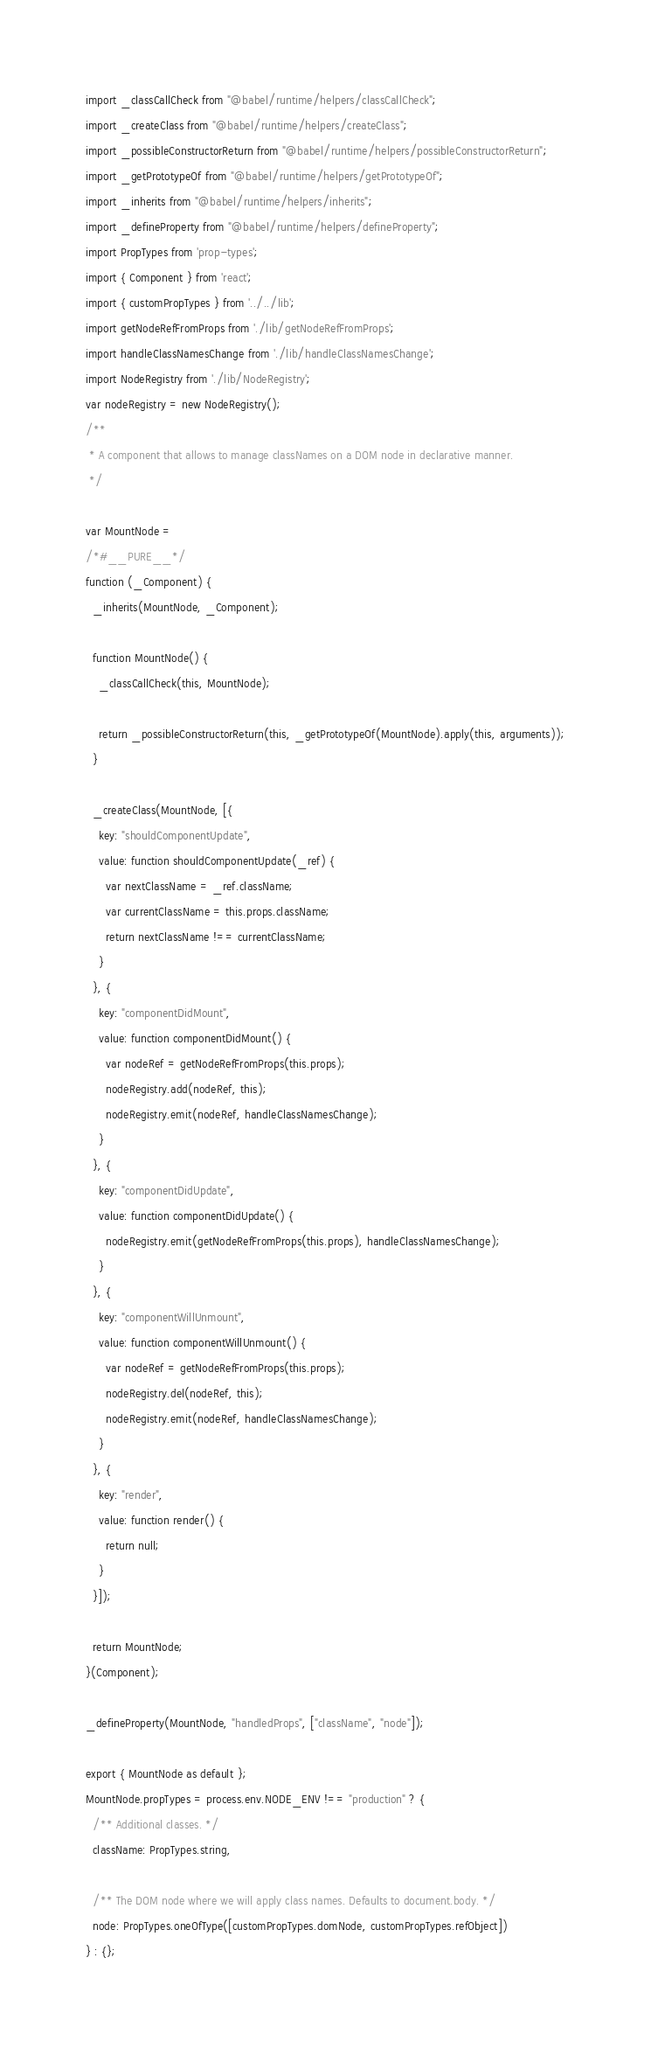<code> <loc_0><loc_0><loc_500><loc_500><_JavaScript_>import _classCallCheck from "@babel/runtime/helpers/classCallCheck";
import _createClass from "@babel/runtime/helpers/createClass";
import _possibleConstructorReturn from "@babel/runtime/helpers/possibleConstructorReturn";
import _getPrototypeOf from "@babel/runtime/helpers/getPrototypeOf";
import _inherits from "@babel/runtime/helpers/inherits";
import _defineProperty from "@babel/runtime/helpers/defineProperty";
import PropTypes from 'prop-types';
import { Component } from 'react';
import { customPropTypes } from '../../lib';
import getNodeRefFromProps from './lib/getNodeRefFromProps';
import handleClassNamesChange from './lib/handleClassNamesChange';
import NodeRegistry from './lib/NodeRegistry';
var nodeRegistry = new NodeRegistry();
/**
 * A component that allows to manage classNames on a DOM node in declarative manner.
 */

var MountNode =
/*#__PURE__*/
function (_Component) {
  _inherits(MountNode, _Component);

  function MountNode() {
    _classCallCheck(this, MountNode);

    return _possibleConstructorReturn(this, _getPrototypeOf(MountNode).apply(this, arguments));
  }

  _createClass(MountNode, [{
    key: "shouldComponentUpdate",
    value: function shouldComponentUpdate(_ref) {
      var nextClassName = _ref.className;
      var currentClassName = this.props.className;
      return nextClassName !== currentClassName;
    }
  }, {
    key: "componentDidMount",
    value: function componentDidMount() {
      var nodeRef = getNodeRefFromProps(this.props);
      nodeRegistry.add(nodeRef, this);
      nodeRegistry.emit(nodeRef, handleClassNamesChange);
    }
  }, {
    key: "componentDidUpdate",
    value: function componentDidUpdate() {
      nodeRegistry.emit(getNodeRefFromProps(this.props), handleClassNamesChange);
    }
  }, {
    key: "componentWillUnmount",
    value: function componentWillUnmount() {
      var nodeRef = getNodeRefFromProps(this.props);
      nodeRegistry.del(nodeRef, this);
      nodeRegistry.emit(nodeRef, handleClassNamesChange);
    }
  }, {
    key: "render",
    value: function render() {
      return null;
    }
  }]);

  return MountNode;
}(Component);

_defineProperty(MountNode, "handledProps", ["className", "node"]);

export { MountNode as default };
MountNode.propTypes = process.env.NODE_ENV !== "production" ? {
  /** Additional classes. */
  className: PropTypes.string,

  /** The DOM node where we will apply class names. Defaults to document.body. */
  node: PropTypes.oneOfType([customPropTypes.domNode, customPropTypes.refObject])
} : {};
</code> 